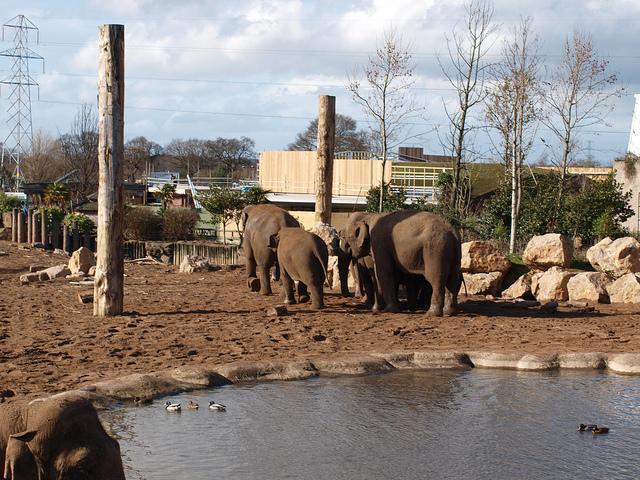What body of water is this?
Select the accurate answer and provide explanation: 'Answer: answer
Rationale: rationale.'
Options: Pool, pond, ocean, swamp. Answer: pond.
Rationale: Elephants are near a small body of water with ducks in it. 